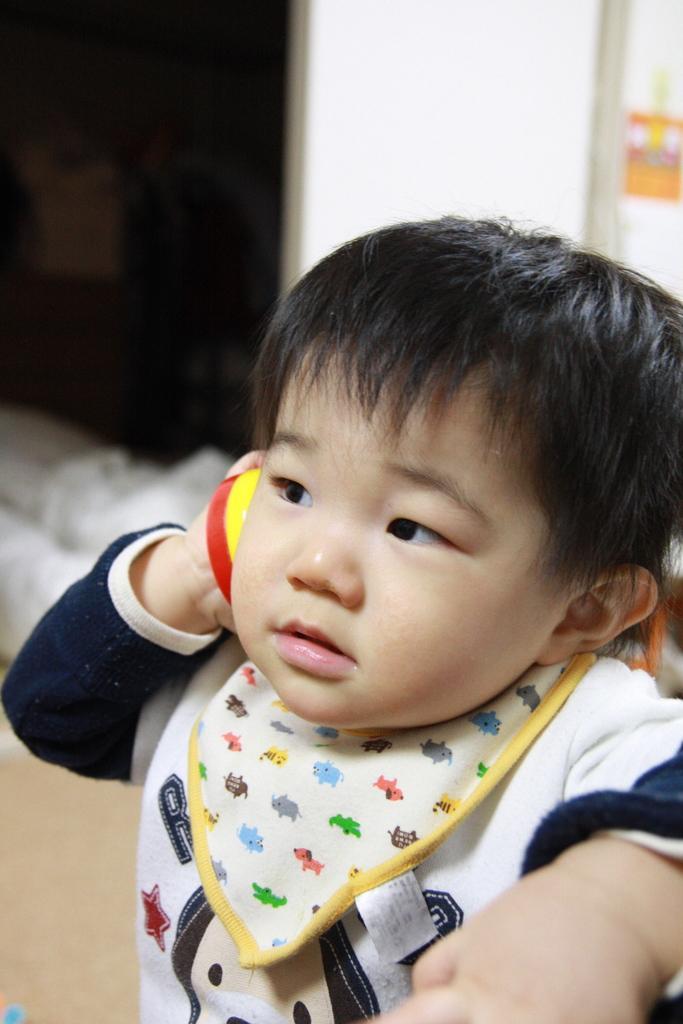In one or two sentences, can you explain what this image depicts? In this image, there is a kid holding a red and yellow color object, at the background there is a white color wall. 